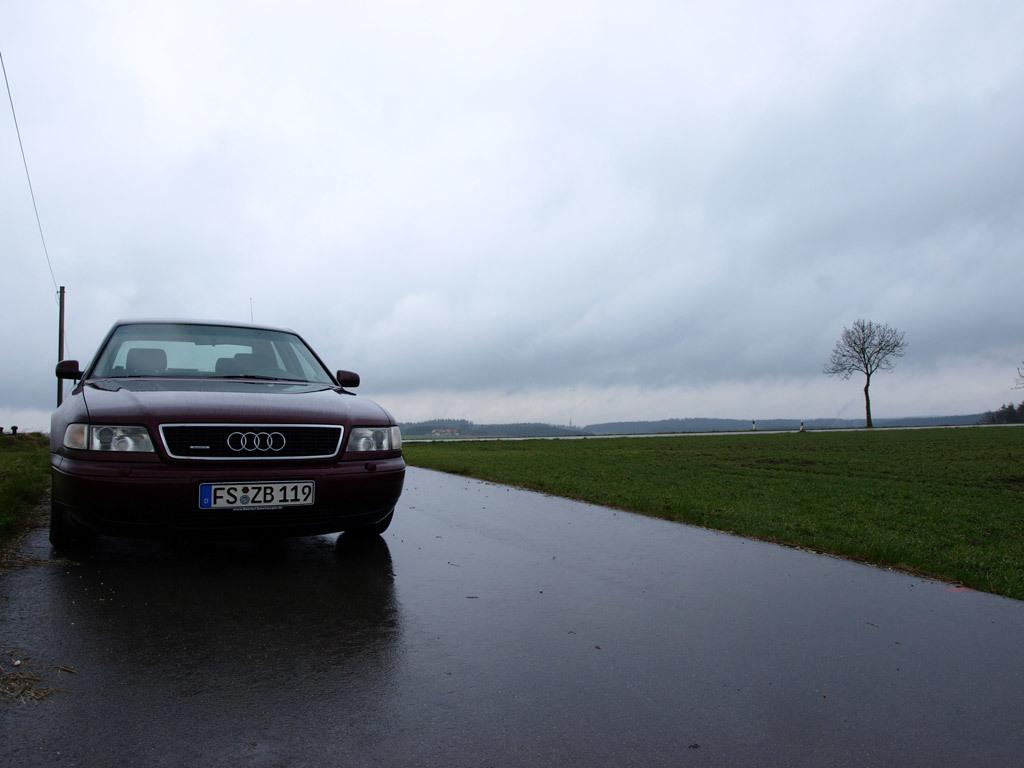<image>
Summarize the visual content of the image. a Mercedes car that has the letter F on the license plate 